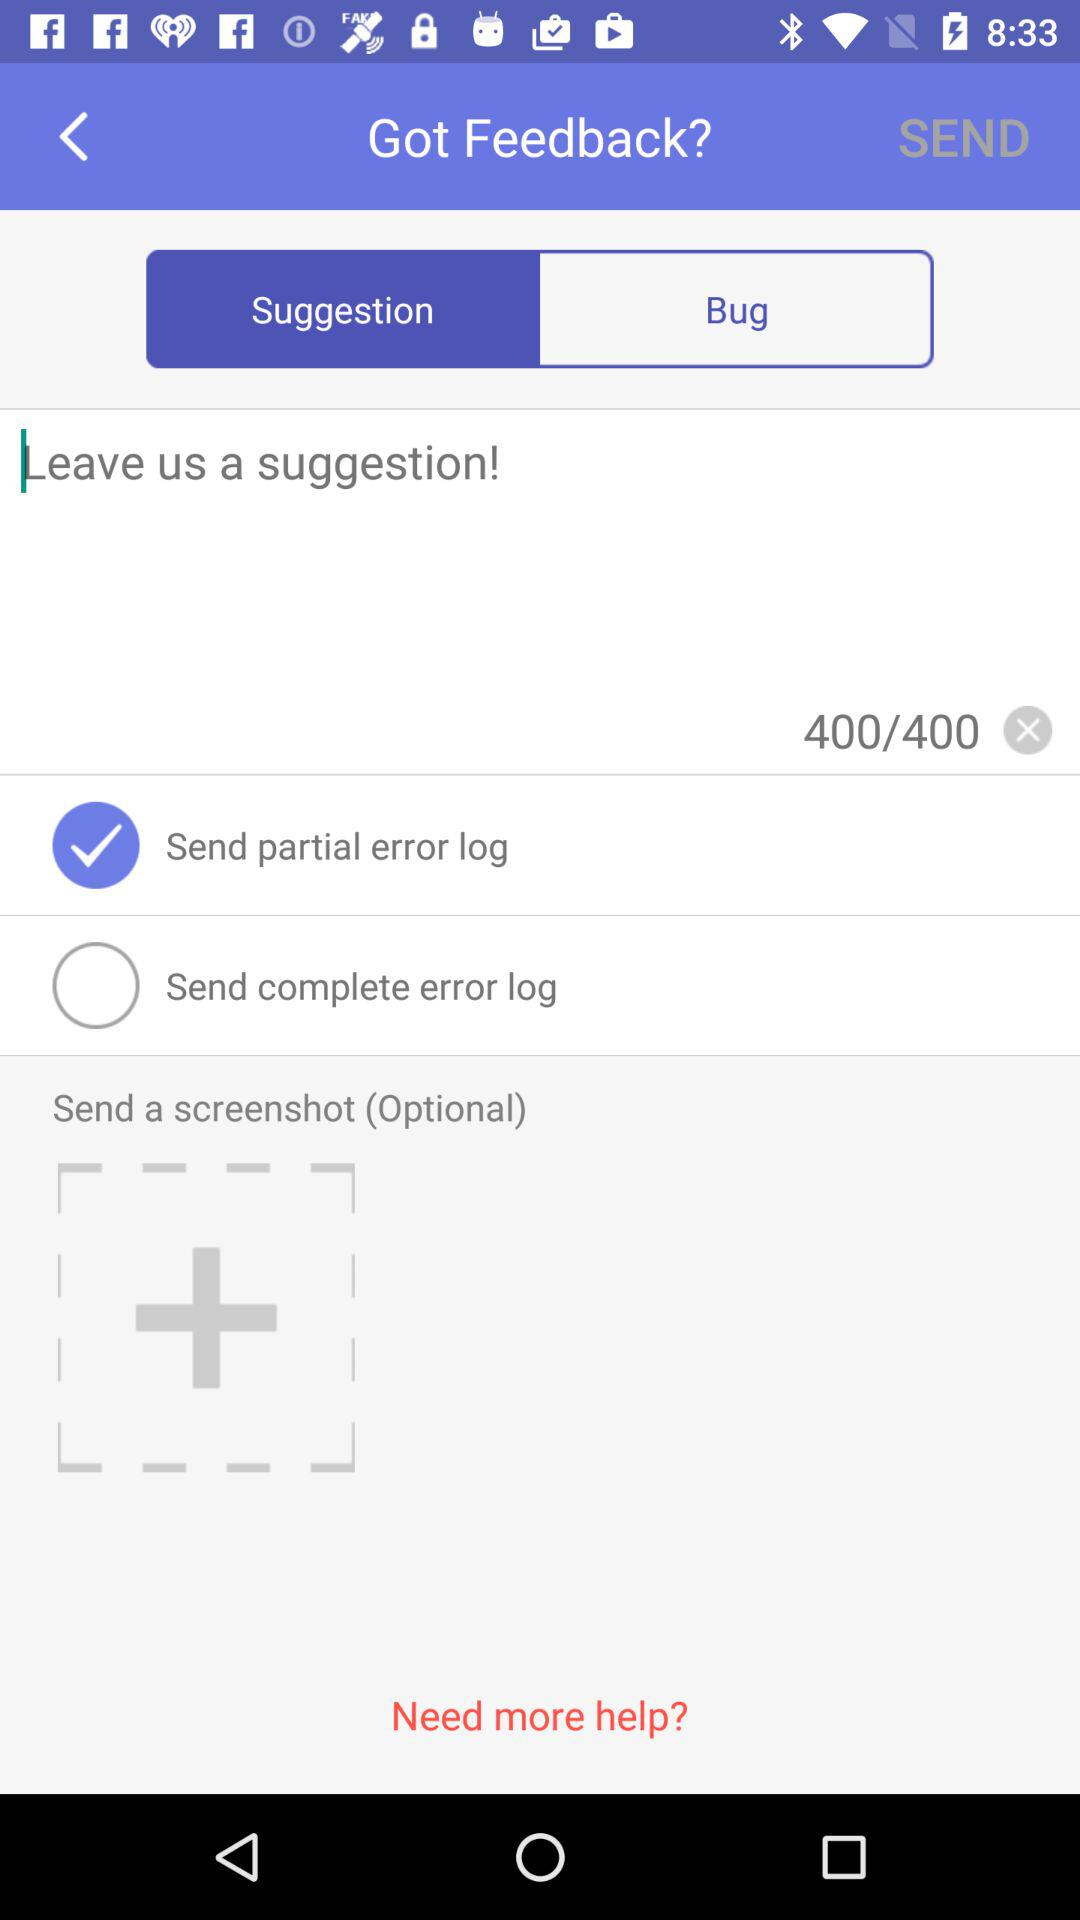Which tab is selected? The selected tab is "Suggestion". 